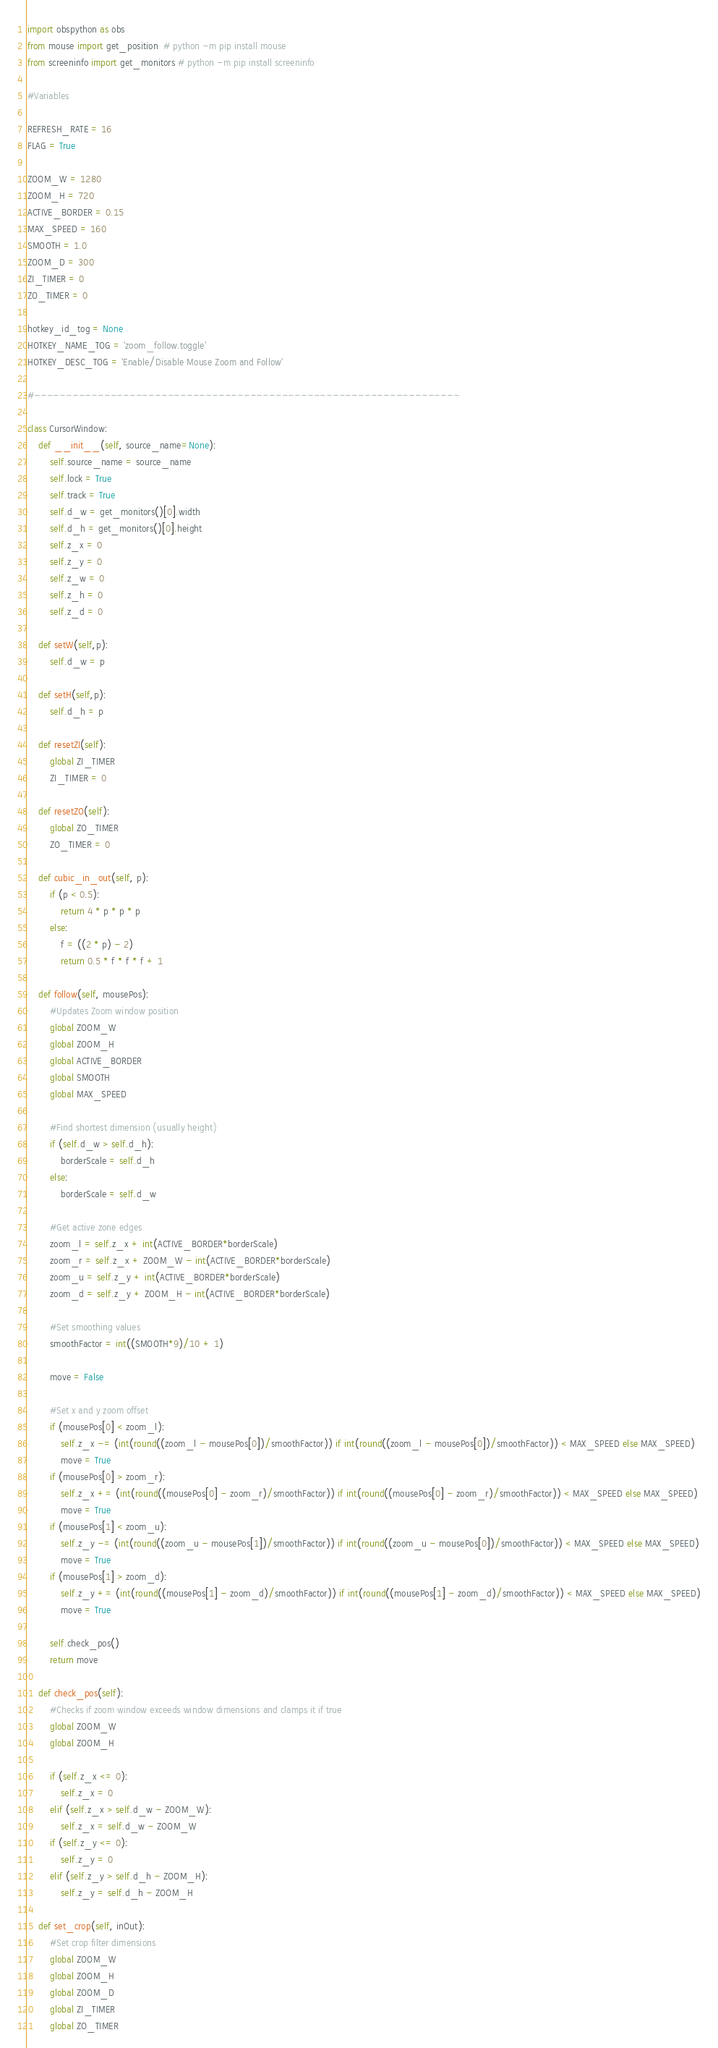<code> <loc_0><loc_0><loc_500><loc_500><_Python_>import obspython as obs
from mouse import get_position  # python -m pip install mouse
from screeninfo import get_monitors # python -m pip install screeninfo

#Variables

REFRESH_RATE = 16
FLAG = True

ZOOM_W = 1280
ZOOM_H = 720
ACTIVE_BORDER = 0.15
MAX_SPEED = 160
SMOOTH = 1.0
ZOOM_D = 300
ZI_TIMER = 0
ZO_TIMER = 0

hotkey_id_tog = None
HOTKEY_NAME_TOG = 'zoom_follow.toggle'
HOTKEY_DESC_TOG = 'Enable/Disable Mouse Zoom and Follow'

#-------------------------------------------------------------------

class CursorWindow:
    def __init__(self, source_name=None):
        self.source_name = source_name
        self.lock = True
        self.track = True
        self.d_w = get_monitors()[0].width
        self.d_h = get_monitors()[0].height
        self.z_x = 0
        self.z_y = 0
        self.z_w = 0
        self.z_h = 0
        self.z_d = 0

    def setW(self,p):
        self.d_w = p
    
    def setH(self,p):
        self.d_h = p

    def resetZI(self):
        global ZI_TIMER
        ZI_TIMER = 0
    
    def resetZO(self):
        global ZO_TIMER
        ZO_TIMER = 0

    def cubic_in_out(self, p):
        if (p < 0.5):
            return 4 * p * p * p
        else:
            f = ((2 * p) - 2)
            return 0.5 * f * f * f + 1

    def follow(self, mousePos):
        #Updates Zoom window position
        global ZOOM_W
        global ZOOM_H
        global ACTIVE_BORDER
        global SMOOTH
        global MAX_SPEED

        #Find shortest dimension (usually height)
        if (self.d_w > self.d_h):
            borderScale = self.d_h
        else:
            borderScale = self.d_w
        
        #Get active zone edges
        zoom_l = self.z_x + int(ACTIVE_BORDER*borderScale)
        zoom_r = self.z_x + ZOOM_W - int(ACTIVE_BORDER*borderScale)
        zoom_u = self.z_y + int(ACTIVE_BORDER*borderScale)
        zoom_d = self.z_y + ZOOM_H - int(ACTIVE_BORDER*borderScale)

        #Set smoothing values
        smoothFactor = int((SMOOTH*9)/10 + 1)
        
        move = False

        #Set x and y zoom offset
        if (mousePos[0] < zoom_l):
            self.z_x -= (int(round((zoom_l - mousePos[0])/smoothFactor)) if int(round((zoom_l - mousePos[0])/smoothFactor)) < MAX_SPEED else MAX_SPEED)
            move = True
        if (mousePos[0] > zoom_r):
            self.z_x += (int(round((mousePos[0] - zoom_r)/smoothFactor)) if int(round((mousePos[0] - zoom_r)/smoothFactor)) < MAX_SPEED else MAX_SPEED)
            move = True
        if (mousePos[1] < zoom_u):
            self.z_y -= (int(round((zoom_u - mousePos[1])/smoothFactor)) if int(round((zoom_u - mousePos[0])/smoothFactor)) < MAX_SPEED else MAX_SPEED)
            move = True
        if (mousePos[1] > zoom_d):
            self.z_y += (int(round((mousePos[1] - zoom_d)/smoothFactor)) if int(round((mousePos[1] - zoom_d)/smoothFactor)) < MAX_SPEED else MAX_SPEED)
            move = True
        
        self.check_pos()
        return move 
    
    def check_pos(self):
        #Checks if zoom window exceeds window dimensions and clamps it if true
        global ZOOM_W
        global ZOOM_H

        if (self.z_x <= 0):
            self.z_x = 0
        elif (self.z_x > self.d_w - ZOOM_W):
            self.z_x = self.d_w - ZOOM_W
        if (self.z_y <= 0):
            self.z_y = 0
        elif (self.z_y > self.d_h - ZOOM_H):
            self.z_y = self.d_h - ZOOM_H

    def set_crop(self, inOut):
        #Set crop filter dimensions
        global ZOOM_W
        global ZOOM_H
        global ZOOM_D
        global ZI_TIMER
        global ZO_TIMER
</code> 